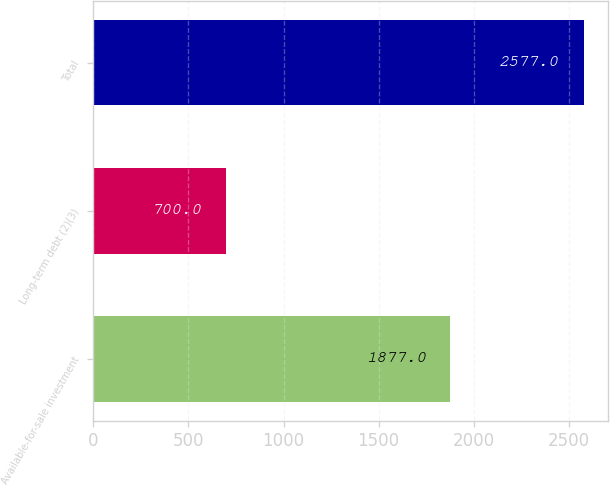Convert chart to OTSL. <chart><loc_0><loc_0><loc_500><loc_500><bar_chart><fcel>Available-for-sale investment<fcel>Long-term debt (2)(3)<fcel>Total<nl><fcel>1877<fcel>700<fcel>2577<nl></chart> 